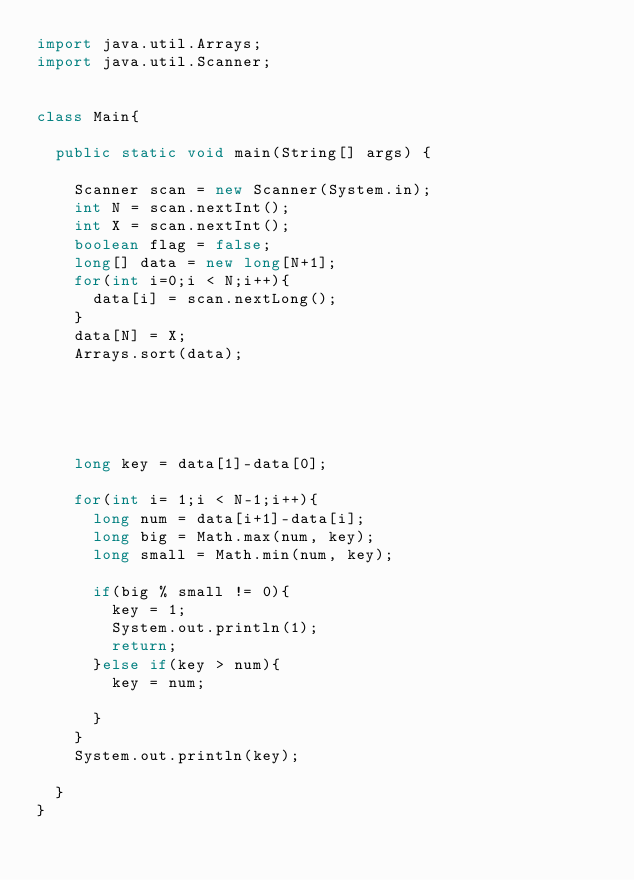<code> <loc_0><loc_0><loc_500><loc_500><_Java_>import java.util.Arrays;
import java.util.Scanner;


class Main{

	public static void main(String[] args) {

		Scanner scan = new Scanner(System.in);
		int N = scan.nextInt();
		int X = scan.nextInt();
		boolean flag = false;
		long[] data = new long[N+1];
		for(int i=0;i < N;i++){
			data[i] = scan.nextLong();
		}
		data[N] = X;
		Arrays.sort(data);
		

		
		

		long key = data[1]-data[0];
		
		for(int i= 1;i < N-1;i++){
			long num = data[i+1]-data[i];
			long big = Math.max(num, key);
			long small = Math.min(num, key);

			if(big % small != 0){
				key = 1;
				System.out.println(1);
				return;
			}else if(key > num){
				key = num;
				
			}
		}
		System.out.println(key);

	}
}
</code> 